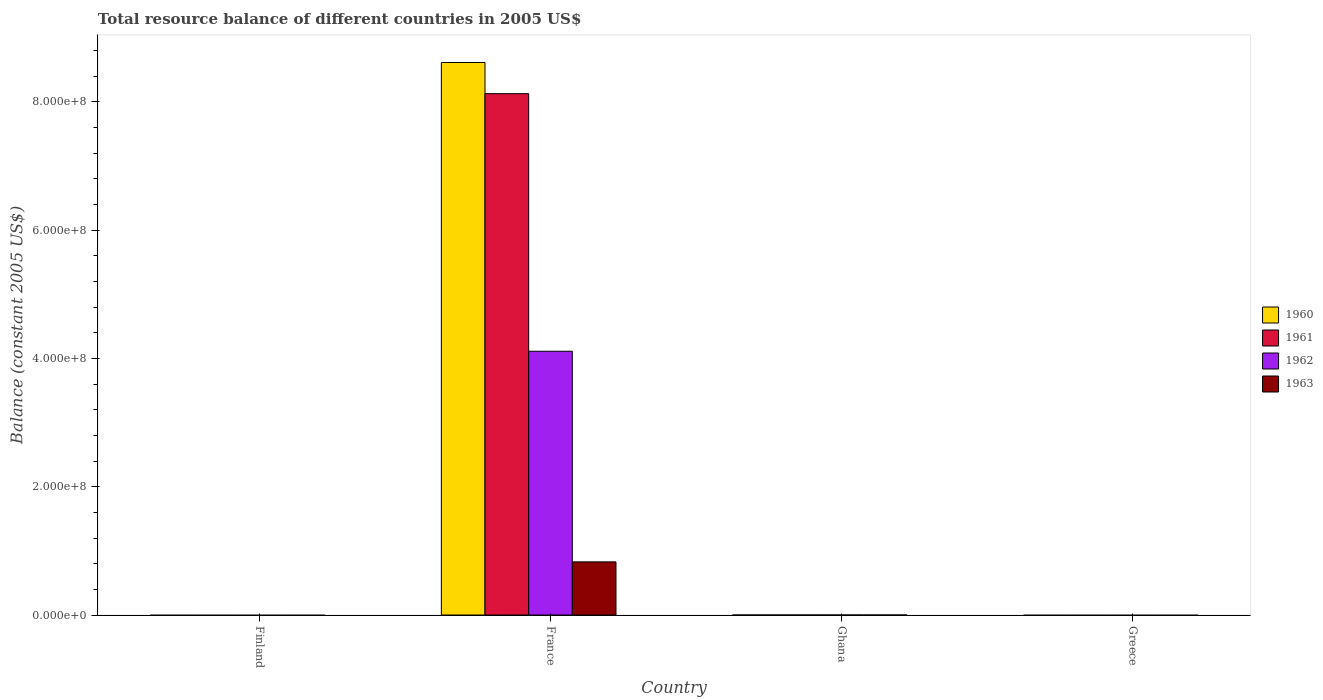How many different coloured bars are there?
Provide a succinct answer. 4. Are the number of bars per tick equal to the number of legend labels?
Give a very brief answer. No. How many bars are there on the 1st tick from the left?
Ensure brevity in your answer.  0. What is the label of the 1st group of bars from the left?
Your response must be concise. Finland. What is the total resource balance in 1961 in Finland?
Make the answer very short. 0. Across all countries, what is the maximum total resource balance in 1962?
Offer a terse response. 4.11e+08. Across all countries, what is the minimum total resource balance in 1962?
Offer a very short reply. 0. What is the total total resource balance in 1963 in the graph?
Provide a short and direct response. 8.29e+07. What is the difference between the total resource balance in 1962 in France and the total resource balance in 1960 in Finland?
Provide a short and direct response. 4.11e+08. What is the average total resource balance in 1961 per country?
Ensure brevity in your answer.  2.03e+08. What is the difference between the total resource balance of/in 1962 and total resource balance of/in 1960 in France?
Provide a short and direct response. -4.50e+08. What is the difference between the highest and the lowest total resource balance in 1963?
Keep it short and to the point. 8.29e+07. Is it the case that in every country, the sum of the total resource balance in 1963 and total resource balance in 1962 is greater than the total resource balance in 1960?
Give a very brief answer. No. Are all the bars in the graph horizontal?
Provide a succinct answer. No. How many countries are there in the graph?
Provide a succinct answer. 4. What is the difference between two consecutive major ticks on the Y-axis?
Make the answer very short. 2.00e+08. Are the values on the major ticks of Y-axis written in scientific E-notation?
Offer a very short reply. Yes. What is the title of the graph?
Provide a succinct answer. Total resource balance of different countries in 2005 US$. What is the label or title of the X-axis?
Offer a terse response. Country. What is the label or title of the Y-axis?
Provide a short and direct response. Balance (constant 2005 US$). What is the Balance (constant 2005 US$) of 1960 in Finland?
Your answer should be compact. 0. What is the Balance (constant 2005 US$) of 1960 in France?
Your response must be concise. 8.62e+08. What is the Balance (constant 2005 US$) in 1961 in France?
Offer a very short reply. 8.13e+08. What is the Balance (constant 2005 US$) in 1962 in France?
Make the answer very short. 4.11e+08. What is the Balance (constant 2005 US$) of 1963 in France?
Make the answer very short. 8.29e+07. What is the Balance (constant 2005 US$) in 1960 in Ghana?
Offer a very short reply. 0. What is the Balance (constant 2005 US$) of 1962 in Ghana?
Provide a short and direct response. 0. What is the Balance (constant 2005 US$) of 1961 in Greece?
Ensure brevity in your answer.  0. What is the Balance (constant 2005 US$) of 1963 in Greece?
Your answer should be compact. 0. Across all countries, what is the maximum Balance (constant 2005 US$) of 1960?
Offer a terse response. 8.62e+08. Across all countries, what is the maximum Balance (constant 2005 US$) of 1961?
Provide a short and direct response. 8.13e+08. Across all countries, what is the maximum Balance (constant 2005 US$) in 1962?
Ensure brevity in your answer.  4.11e+08. Across all countries, what is the maximum Balance (constant 2005 US$) of 1963?
Provide a succinct answer. 8.29e+07. Across all countries, what is the minimum Balance (constant 2005 US$) in 1960?
Give a very brief answer. 0. What is the total Balance (constant 2005 US$) in 1960 in the graph?
Your answer should be very brief. 8.62e+08. What is the total Balance (constant 2005 US$) of 1961 in the graph?
Keep it short and to the point. 8.13e+08. What is the total Balance (constant 2005 US$) in 1962 in the graph?
Provide a succinct answer. 4.11e+08. What is the total Balance (constant 2005 US$) of 1963 in the graph?
Ensure brevity in your answer.  8.29e+07. What is the average Balance (constant 2005 US$) of 1960 per country?
Your response must be concise. 2.15e+08. What is the average Balance (constant 2005 US$) in 1961 per country?
Offer a very short reply. 2.03e+08. What is the average Balance (constant 2005 US$) in 1962 per country?
Offer a terse response. 1.03e+08. What is the average Balance (constant 2005 US$) of 1963 per country?
Offer a terse response. 2.07e+07. What is the difference between the Balance (constant 2005 US$) in 1960 and Balance (constant 2005 US$) in 1961 in France?
Make the answer very short. 4.86e+07. What is the difference between the Balance (constant 2005 US$) in 1960 and Balance (constant 2005 US$) in 1962 in France?
Give a very brief answer. 4.50e+08. What is the difference between the Balance (constant 2005 US$) in 1960 and Balance (constant 2005 US$) in 1963 in France?
Make the answer very short. 7.79e+08. What is the difference between the Balance (constant 2005 US$) in 1961 and Balance (constant 2005 US$) in 1962 in France?
Give a very brief answer. 4.02e+08. What is the difference between the Balance (constant 2005 US$) of 1961 and Balance (constant 2005 US$) of 1963 in France?
Your answer should be very brief. 7.30e+08. What is the difference between the Balance (constant 2005 US$) in 1962 and Balance (constant 2005 US$) in 1963 in France?
Offer a terse response. 3.28e+08. What is the difference between the highest and the lowest Balance (constant 2005 US$) in 1960?
Keep it short and to the point. 8.62e+08. What is the difference between the highest and the lowest Balance (constant 2005 US$) in 1961?
Your response must be concise. 8.13e+08. What is the difference between the highest and the lowest Balance (constant 2005 US$) in 1962?
Your response must be concise. 4.11e+08. What is the difference between the highest and the lowest Balance (constant 2005 US$) in 1963?
Ensure brevity in your answer.  8.29e+07. 